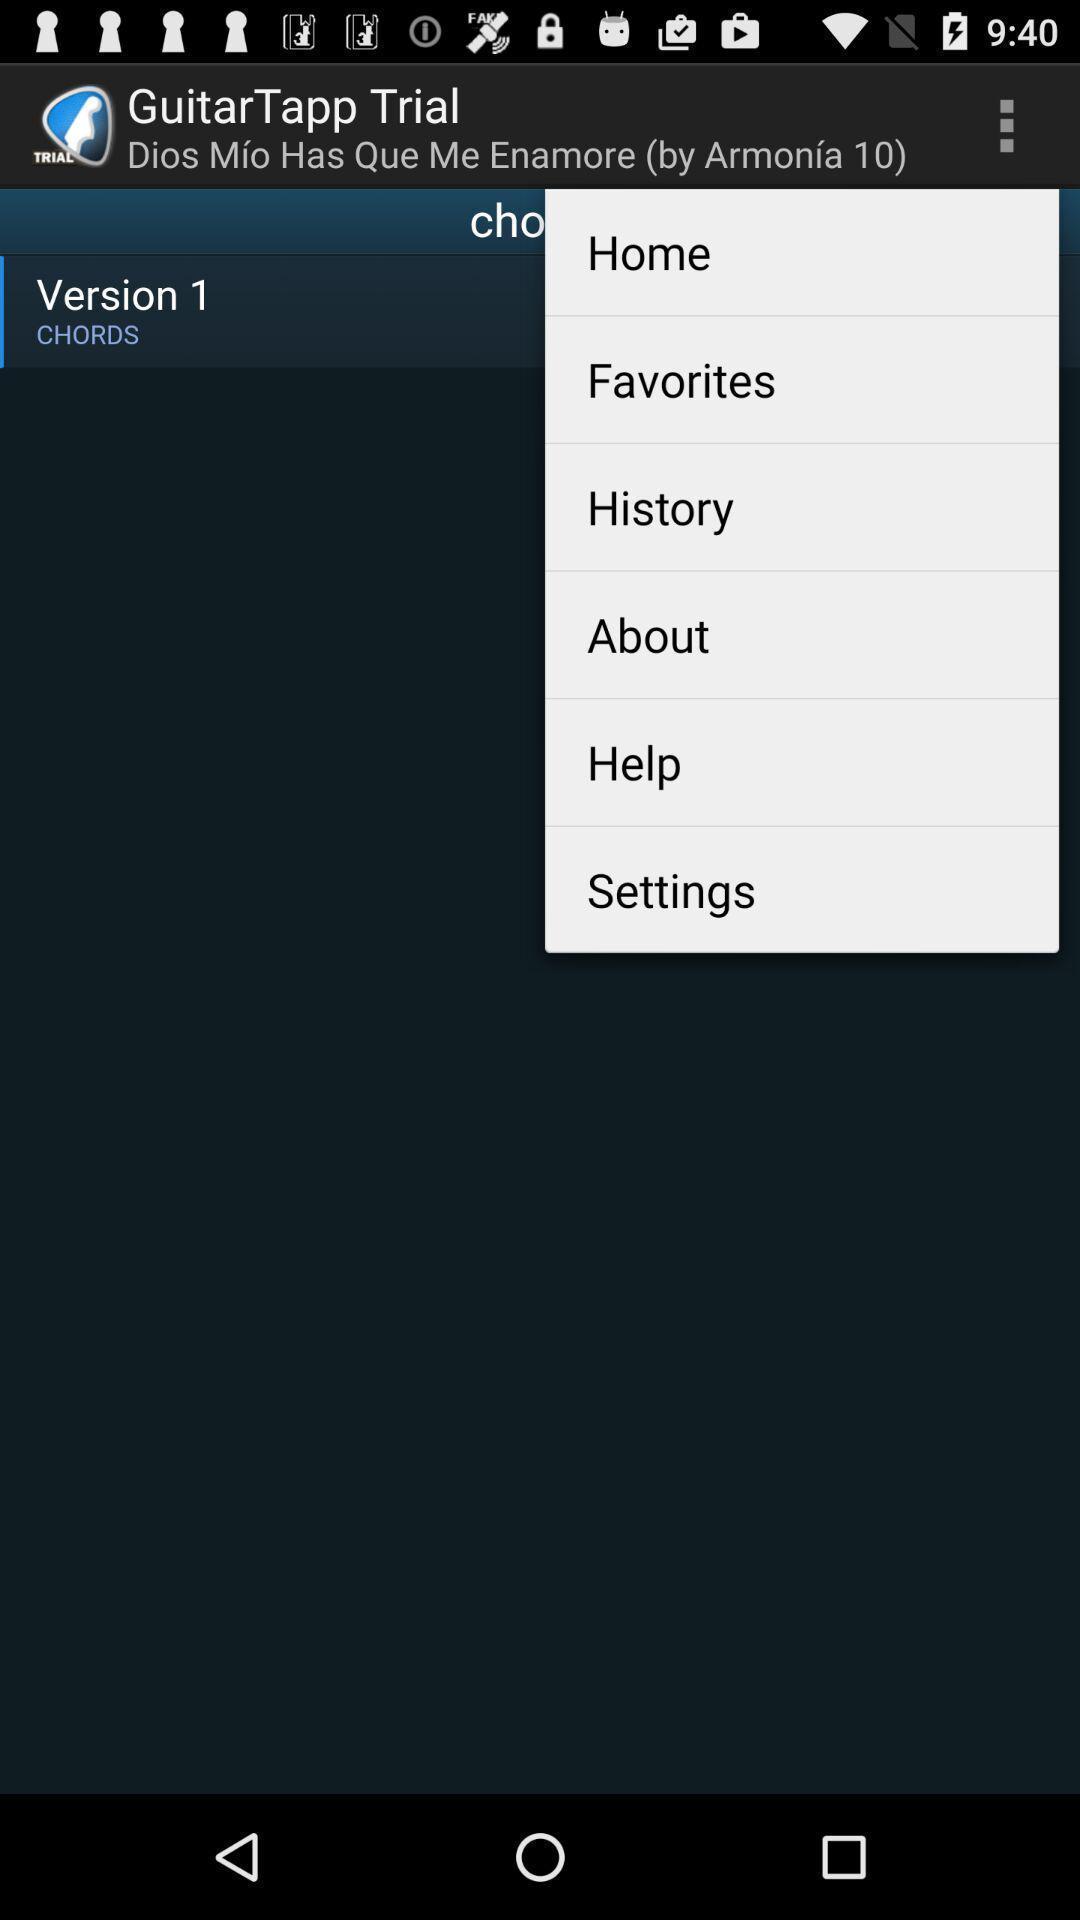Summarize the information in this screenshot. Pop up page displayed includes various options. 